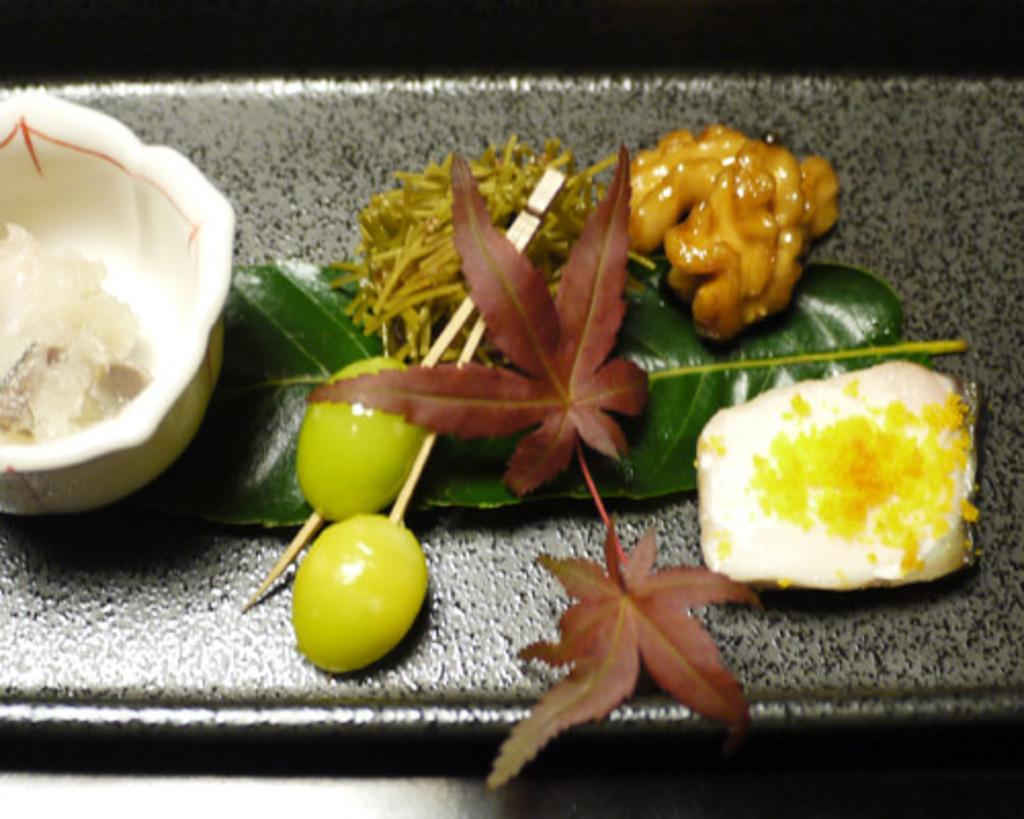What type of food can be seen in the image? There are fruits in the image. What else is present in the image besides the fruits? There are leaves in the image. Can you describe the other items on the surface in the image? Unfortunately, the provided facts do not give any specific details about the other items on the surface. What type of wire is being used to support the flight in the image? There is no flight or wire present in the image; it features fruits and leaves. 